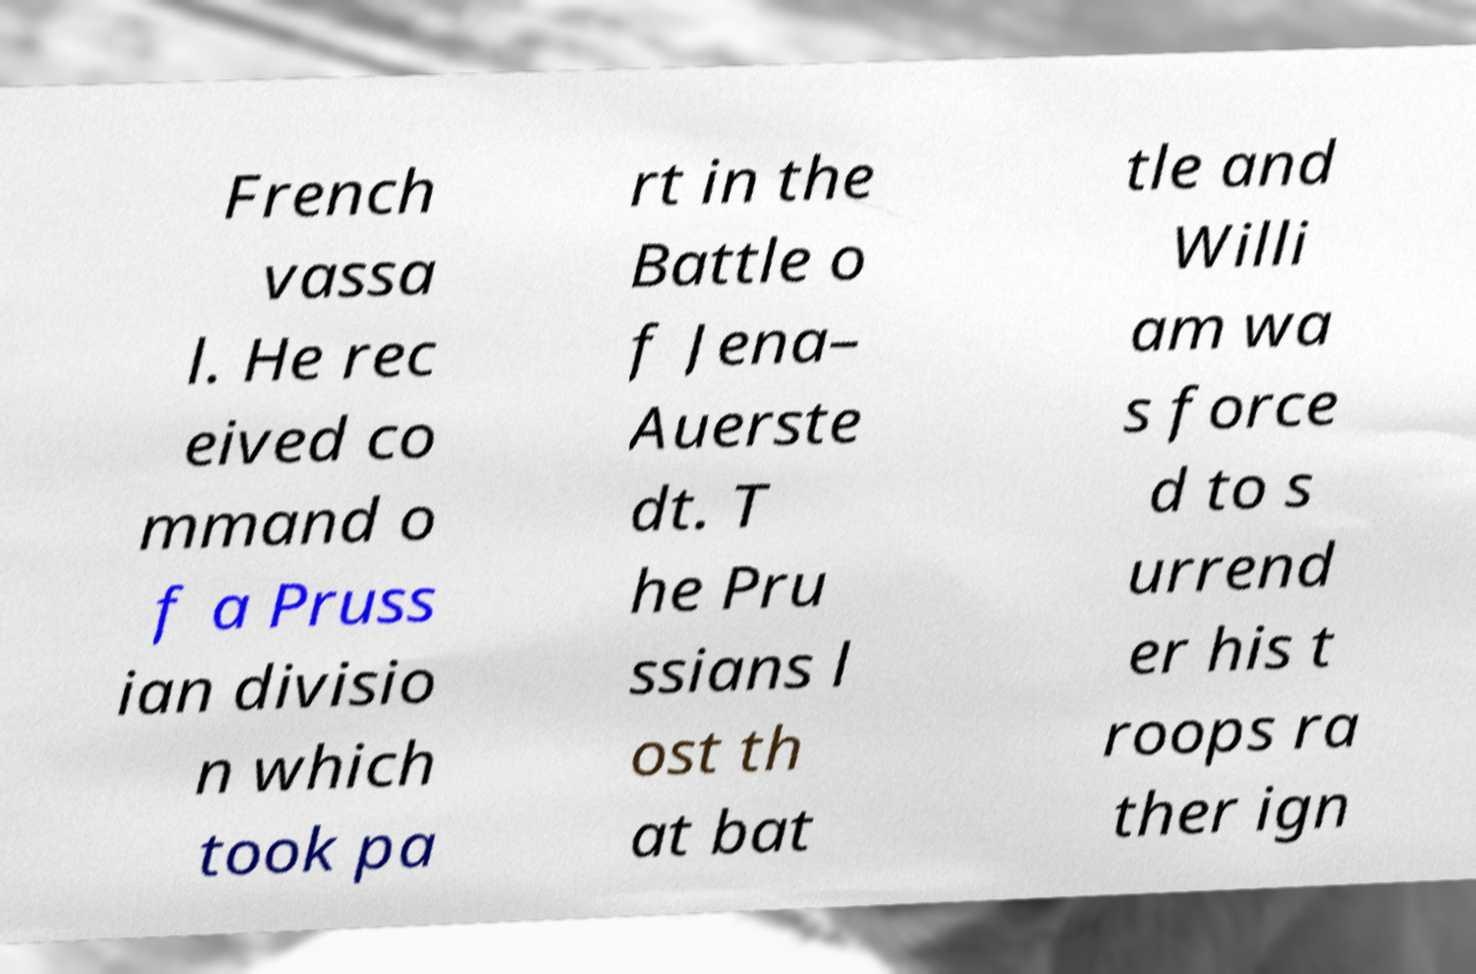Can you read and provide the text displayed in the image?This photo seems to have some interesting text. Can you extract and type it out for me? French vassa l. He rec eived co mmand o f a Pruss ian divisio n which took pa rt in the Battle o f Jena– Auerste dt. T he Pru ssians l ost th at bat tle and Willi am wa s force d to s urrend er his t roops ra ther ign 